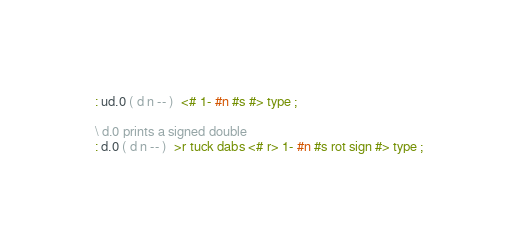<code> <loc_0><loc_0><loc_500><loc_500><_Forth_>: ud.0 ( d n -- )  <# 1- #n #s #> type ;

\ d.0 prints a signed double
: d.0 ( d n -- )  >r tuck dabs <# r> 1- #n #s rot sign #> type ;
</code> 